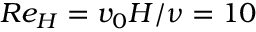<formula> <loc_0><loc_0><loc_500><loc_500>R e _ { H } = v _ { 0 } H / \nu = 1 0</formula> 